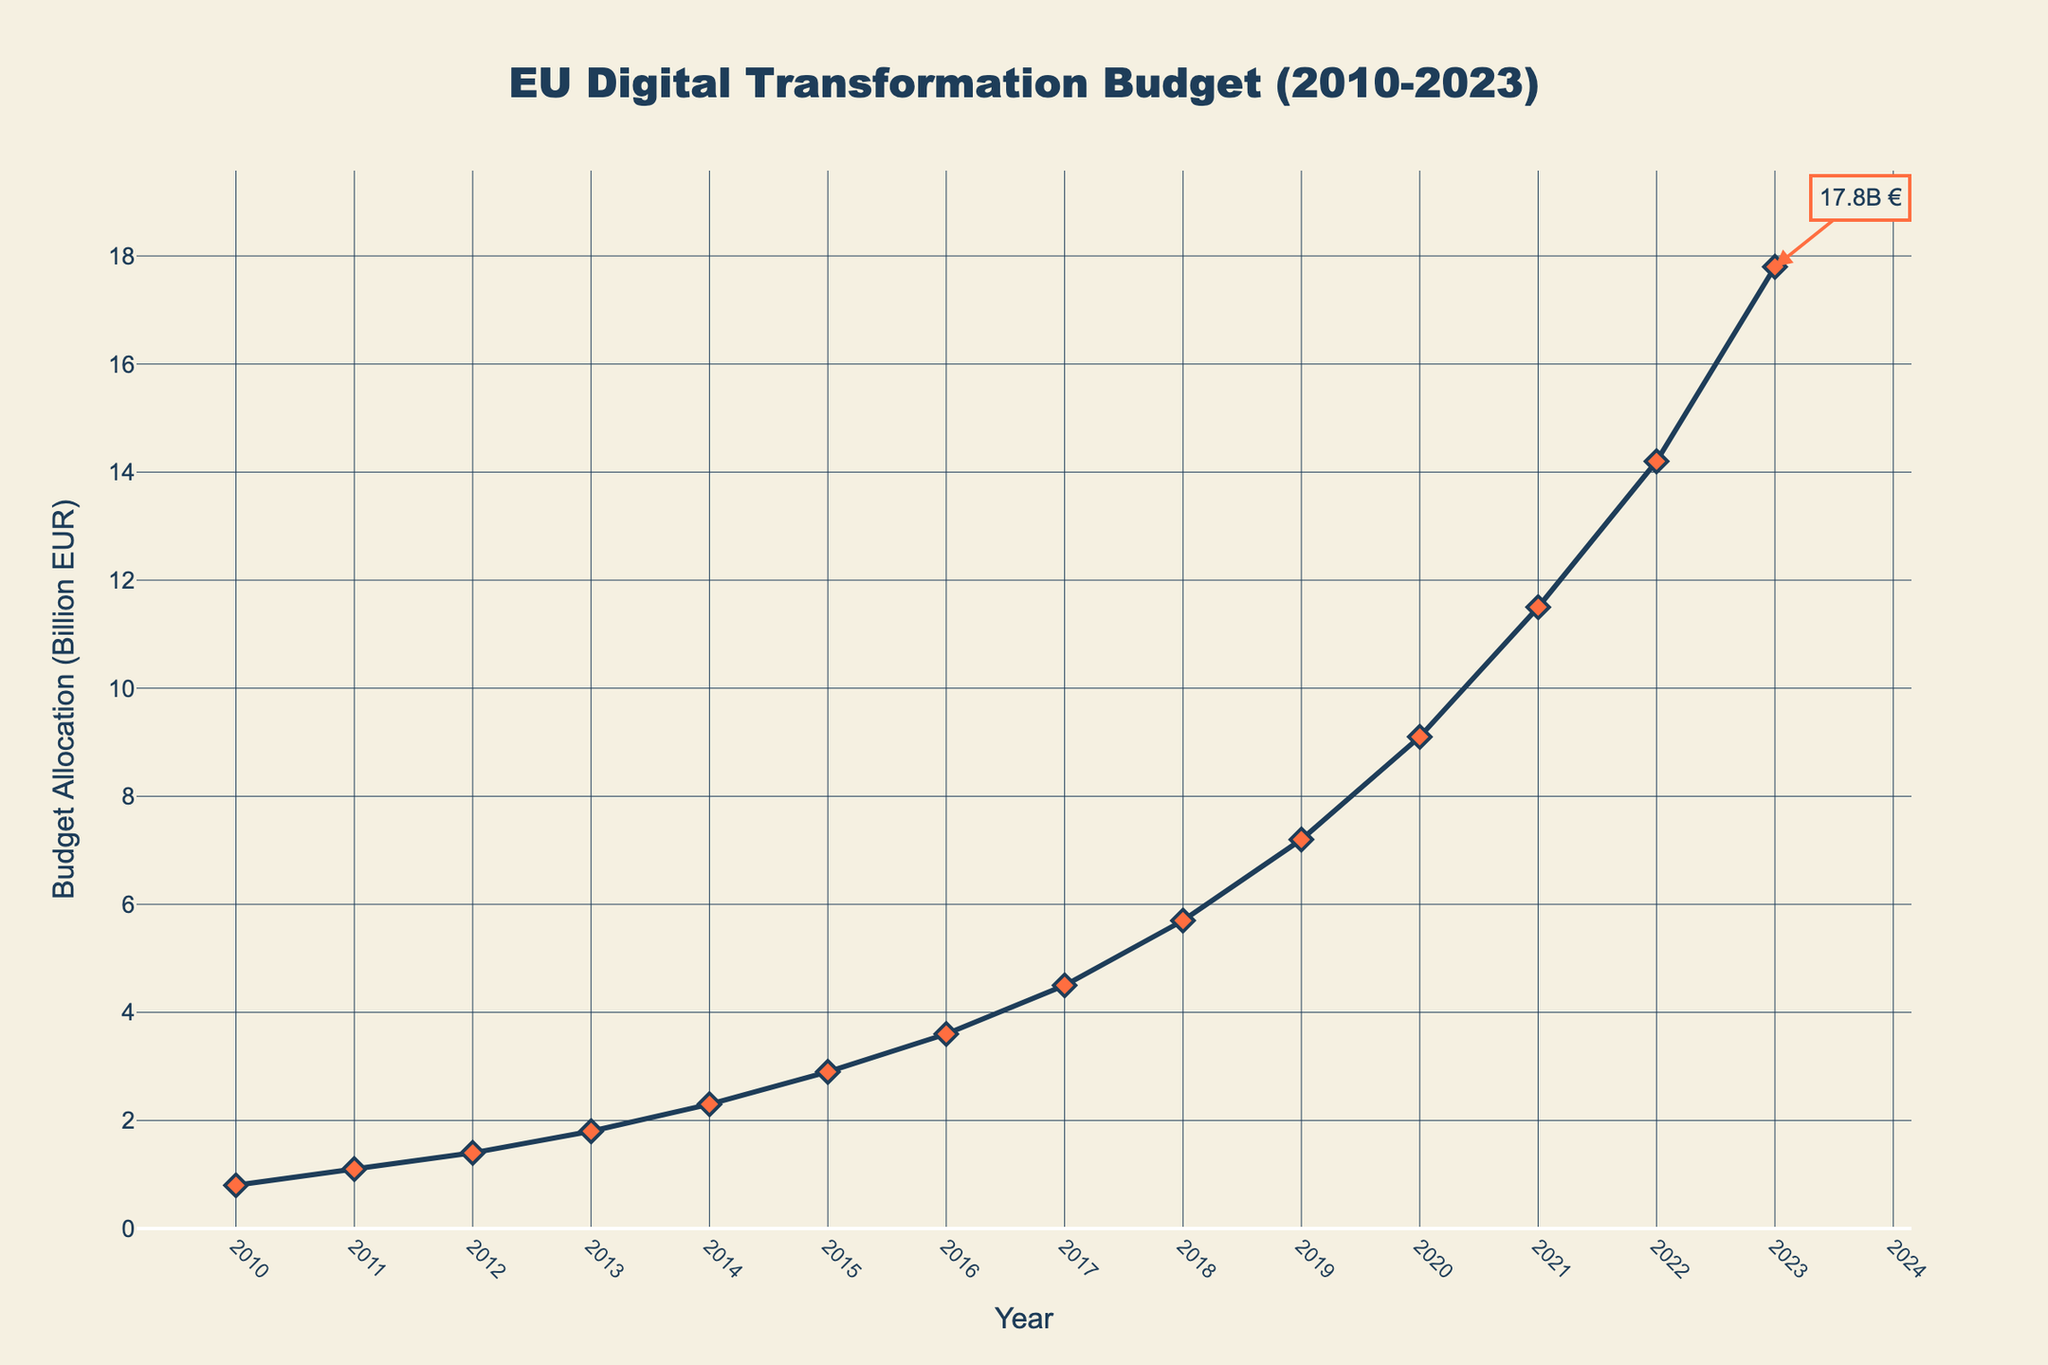What's the budget allocation for the year 2015? The budget allocation for 2015 can be found directly on the figure by looking at the point labeled with the year 2015 on the x-axis. The corresponding point on the y-axis shows the value.
Answer: 2.9 Billion EUR Between which consecutive years did the budget allocation increase the most? To determine this, we need to check the increase in budget allocation between each pair of consecutive years. The increases are: 0.3 (2010-2011), 0.3 (2011-2012), 0.4 (2012-2013), 0.5 (2013-2014), 0.6 (2014-2015), 0.7 (2015-2016), 0.9 (2016-2017), 1.2 (2017-2018), 1.5 (2018-2019), 1.9 (2019-2020), 2.4 (2020-2021), 2.7 (2021-2022), and 3.6 (2022-2023). The largest increase is between 2022 and 2023.
Answer: 2022-2023 What is the total budget allocation from 2010 to 2015? To find the total, sum the budget allocations from 2010 to 2015: 0.8 + 1.1 + 1.4 + 1.8 + 2.3 + 2.9 = 10.3
Answer: 10.3 Billion EUR Which year saw a budget allocation greater than or equal to 10 billion EUR for the first time? Look for the first year on the x-axis where the corresponding y-axis value is 10 billion EUR or more. This is in the year 2021.
Answer: 2021 What is the average budget allocation from 2010 to 2023? To find the average, sum all the budget allocations and then divide by the number of years. The total is 0.8 + 1.1 + 1.4 + 1.8 + 2.3 + 2.9 + 3.6 + 4.5 + 5.7 + 7.2 + 9.1 + 11.5 + 14.2 + 17.8 = 83.9. There are 14 years, so the average is 83.9 / 14 ≈ 5.99.
Answer: 5.99 Billion EUR Comparing 2018 and 2019, which year had the higher budget allocation and by how much? Identify the budget allocations for 2018 (5.7 billion EUR) and 2019 (7.2 billion EUR). Subtract the 2018 value from the 2019 value: 7.2 - 5.7 = 1.5.
Answer: 2019 by 1.5 Billion EUR By what factor did the budget allocation increase from 2010 to 2023? The budget allocation in 2010 was 0.8 billion EUR and in 2023 it was 17.8 billion EUR. Divide the 2023 value by the 2010 value to find the factor: 17.8 / 0.8 = 22.25.
Answer: 22.25 What's the median budget allocation from 2010 to 2023? List the budget allocations in ascending order and find the middle value. The ordered list is: 0.8, 1.1, 1.4, 1.8, 2.3, 2.9, 3.6, 4.5, 5.7, 7.2, 9.1, 11.5, 14.2, 17.8. There are 14 values, the median is the average of the 7th and 8th values: (3.6 + 4.5) / 2 = 4.05.
Answer: 4.05 Billion EUR How does the budget allocation trend visually appear from 2010 to 2023? The budget allocation trend from 2010 to 2023 appears as an upward-sloping line, indicating a consistent increase over time, with noticeably sharper rises in the later years.
Answer: Upward, with sharper increases in later years What visual annotations are added to the plot? The plot includes an annotation on the year 2023 showing the budget allocation value of 17.8 billion EUR with an arrow pointing to the corresponding data point.
Answer: An annotation on the year 2023 with an arrow to the data point 